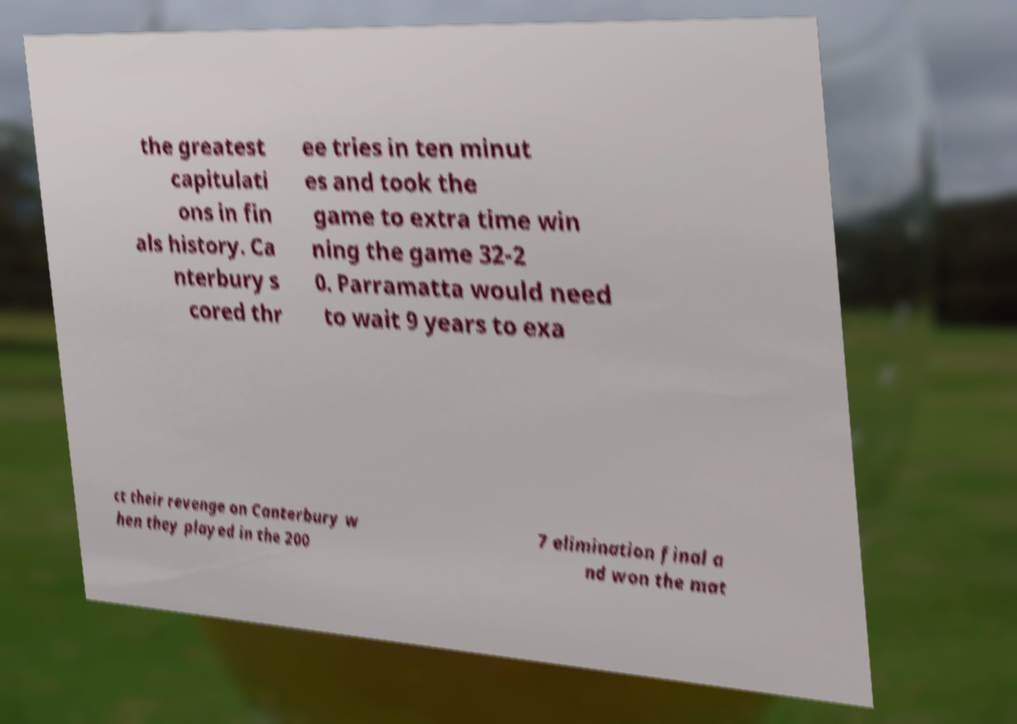For documentation purposes, I need the text within this image transcribed. Could you provide that? the greatest capitulati ons in fin als history. Ca nterbury s cored thr ee tries in ten minut es and took the game to extra time win ning the game 32-2 0. Parramatta would need to wait 9 years to exa ct their revenge on Canterbury w hen they played in the 200 7 elimination final a nd won the mat 